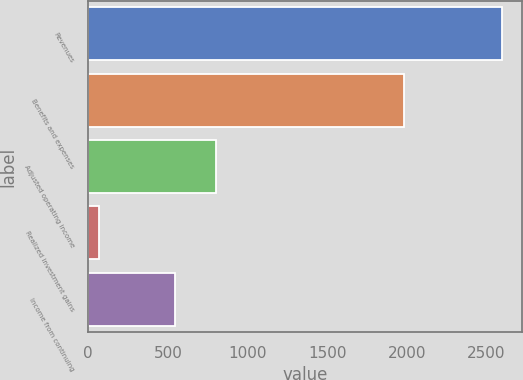Convert chart to OTSL. <chart><loc_0><loc_0><loc_500><loc_500><bar_chart><fcel>Revenues<fcel>Benefits and expenses<fcel>Adjusted operating income<fcel>Realized investment gains<fcel>Income from continuing<nl><fcel>2594<fcel>1980<fcel>800.8<fcel>66<fcel>548<nl></chart> 